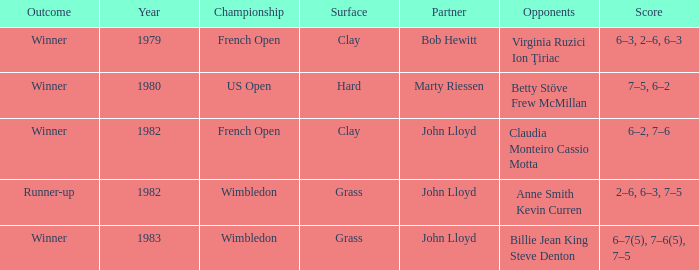What was the total number of matches that had an outcome of Winner, a partner of John Lloyd, and a clay surface? 1.0. 